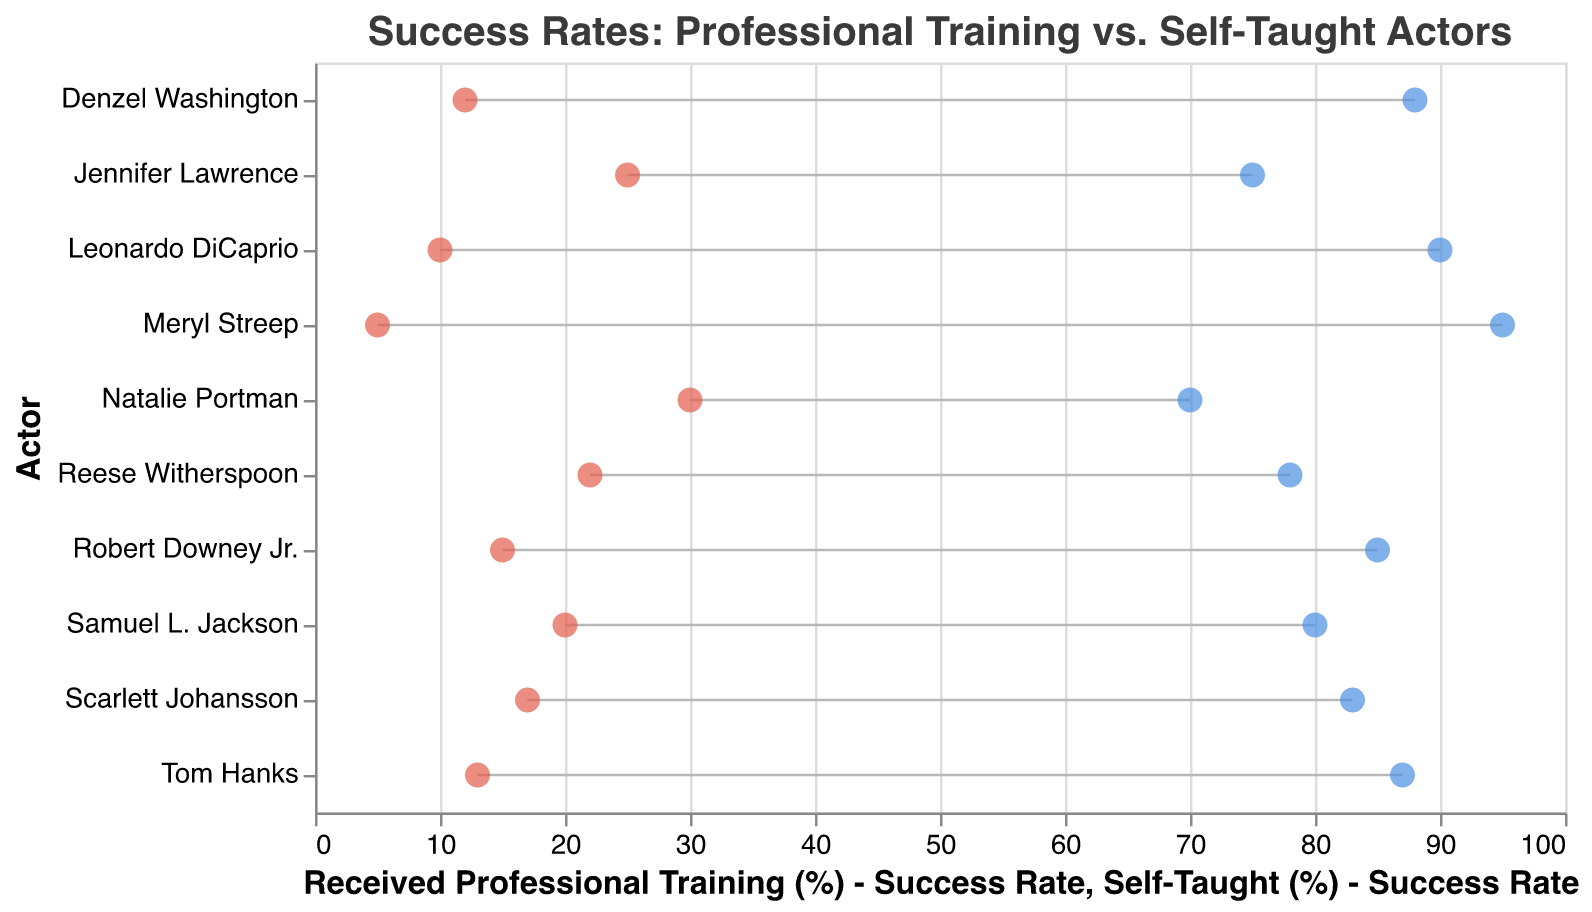What is the title of the figure? The title is displayed at the top of the figure in bold text, indicating the main focus of the plot.
Answer: Success Rates: Professional Training vs. Self-Taught Actors Which actor has the highest success rate for self-taught training? By examining the red circles on the right side of the plot, we can see that Natalie Portman has the highest success rate for self-taught training at 30%.
Answer: Natalie Portman What is the difference in success rate between professional training and self-taught for Leonardo DiCaprio? Leonardo DiCaprio's professional training success rate is 90%, and his self-taught success rate is 10%. The difference is calculated as 90% - 10% = 80%.
Answer: 80% Which actor shows the smallest difference between professional training and self-taught success rates? By observing the differences between the blue and red circles for each actor, we see that Meryl Streep has the smallest difference, with a professional success rate of 95% and self-taught success rate of 5%, resulting in a 90% difference.
Answer: Meryl Streep How many actors have a self-taught success rate of 20% or higher? By counting the number of red circles with values of 20% or above, we see that there are three actors: Samuel L. Jackson (20%), Jennifer Lawrence (25%), and Natalie Portman (30%).
Answer: 3 Which actor has the highest combined success rate from both professional training and self-taught methods? For each actor, sum the success rates from both professional and self-taught methods. The highest combined rate is for Meryl Streep with 95% (professional) + 5% (self-taught) = 100%.
Answer: Meryl Streep What is the success rate for professional training for Robert Downey Jr.? By looking at the blue circle corresponding to Robert Downey Jr., we can see that his success rate for professional training is 85%.
Answer: 85% Which actors have professional training success rates lower than 80%? By examining the blue circles less than 80% on the x-axis, we find that Jennifer Lawrence (75%) and Natalie Portman (70%) fall into this category.
Answer: Jennifer Lawrence, Natalie Portman What is the median value of the professional training success rates for all actors? The professional training success rates are: 95, 87, 83, 90, 80, 75, 85, 70, 88, 78. Arranging these in order: 70, 75, 78, 80, 83, 85, 87, 88, 90, 95, the median is between the 5th and 6th value: (83 + 85) / 2 = 84.
Answer: 84 